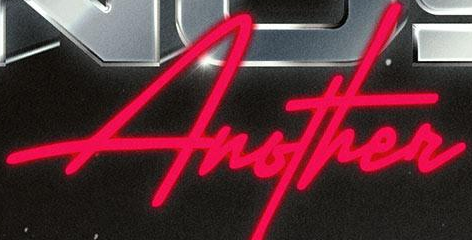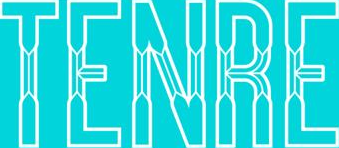Read the text content from these images in order, separated by a semicolon. Another; TENRE 